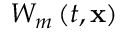Convert formula to latex. <formula><loc_0><loc_0><loc_500><loc_500>W _ { m } \left ( t , x \right )</formula> 